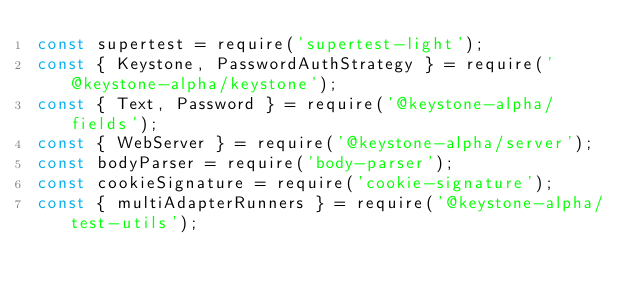<code> <loc_0><loc_0><loc_500><loc_500><_JavaScript_>const supertest = require('supertest-light');
const { Keystone, PasswordAuthStrategy } = require('@keystone-alpha/keystone');
const { Text, Password } = require('@keystone-alpha/fields');
const { WebServer } = require('@keystone-alpha/server');
const bodyParser = require('body-parser');
const cookieSignature = require('cookie-signature');
const { multiAdapterRunners } = require('@keystone-alpha/test-utils');</code> 